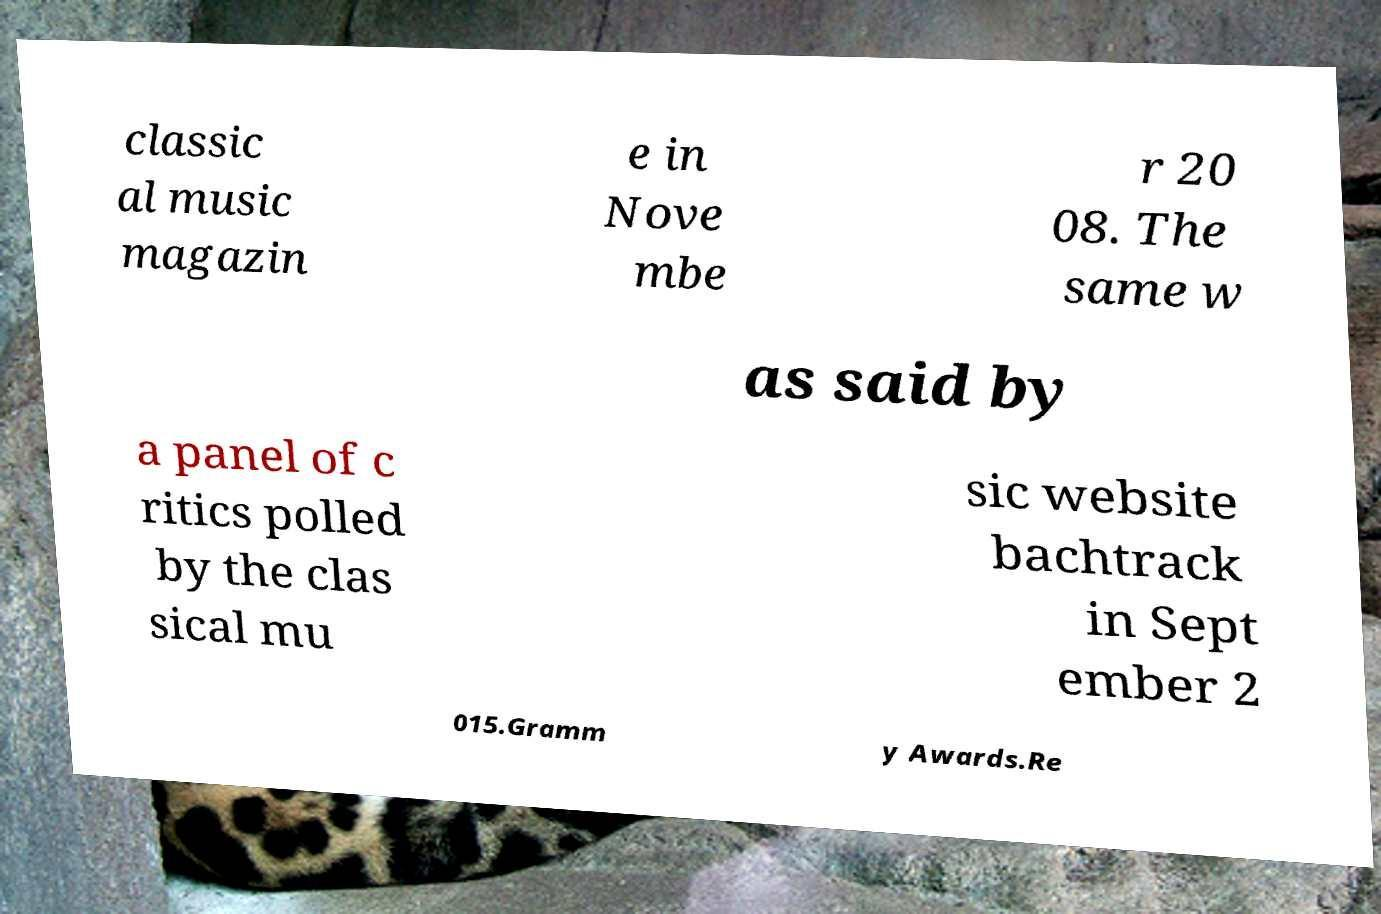Could you extract and type out the text from this image? classic al music magazin e in Nove mbe r 20 08. The same w as said by a panel of c ritics polled by the clas sical mu sic website bachtrack in Sept ember 2 015.Gramm y Awards.Re 